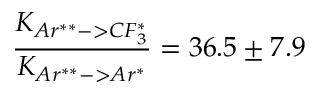<formula> <loc_0><loc_0><loc_500><loc_500>\frac { K _ { A r ^ { * * } - > C F _ { 3 } ^ { * } } } { K _ { A r ^ { * * } - > A r ^ { * } } } = 3 6 . 5 \pm 7 . 9</formula> 